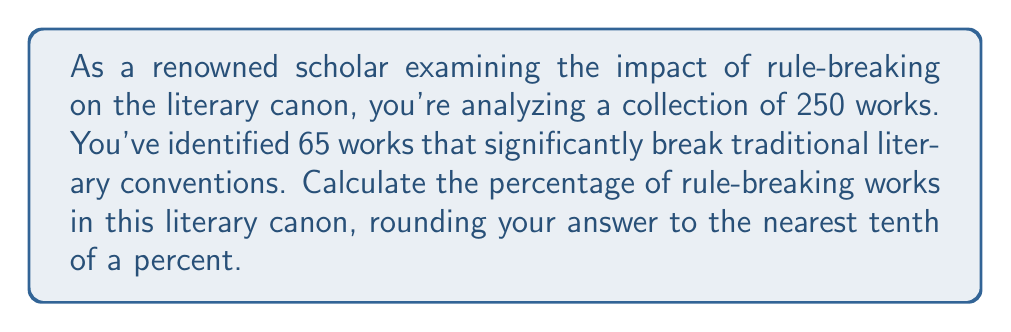Solve this math problem. To calculate the percentage of rule-breaking works in the literary canon, we need to follow these steps:

1. Identify the total number of works and the number of rule-breaking works:
   - Total works: 250
   - Rule-breaking works: 65

2. Use the formula for percentage:
   $$ \text{Percentage} = \frac{\text{Part}}{\text{Whole}} \times 100\% $$

3. Substitute the values into the formula:
   $$ \text{Percentage} = \frac{65}{250} \times 100\% $$

4. Perform the division:
   $$ \frac{65}{250} = 0.26 $$

5. Multiply by 100 to get the percentage:
   $$ 0.26 \times 100\% = 26\% $$

6. Round to the nearest tenth of a percent:
   26% is already rounded to the nearest tenth, so no further rounding is necessary.

Therefore, the percentage of rule-breaking works in this literary canon is 26.0%.
Answer: 26.0% 